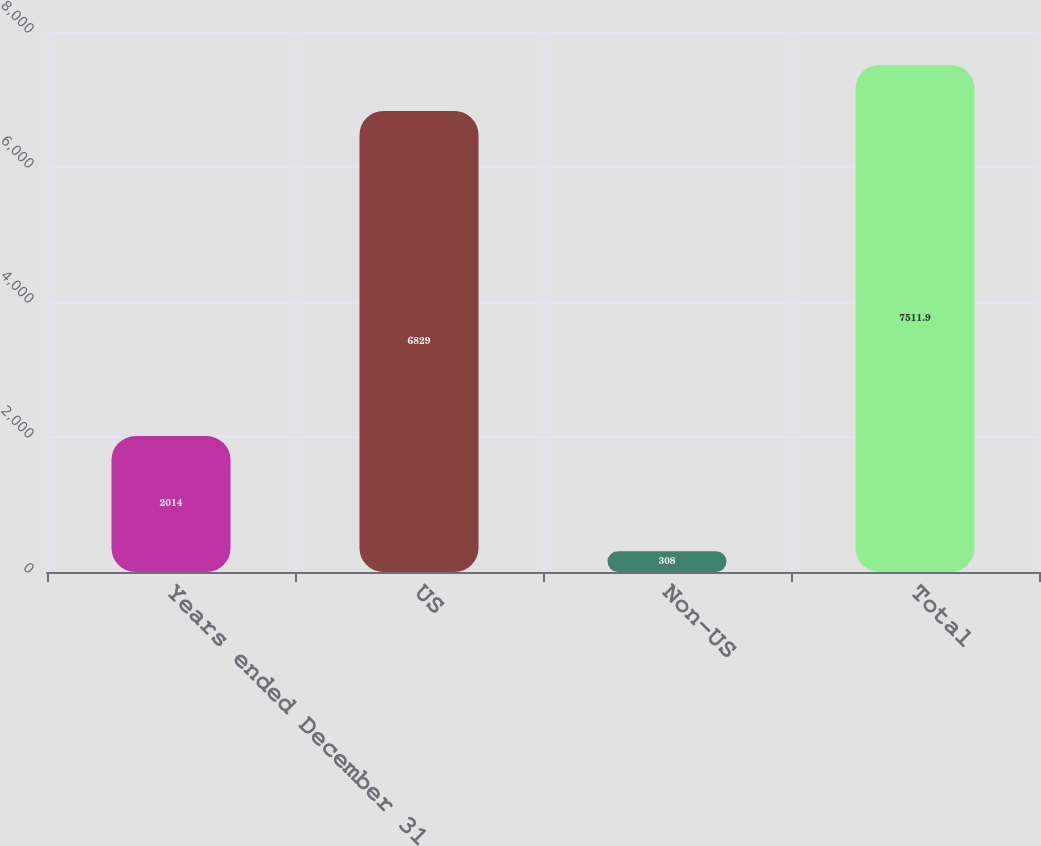Convert chart to OTSL. <chart><loc_0><loc_0><loc_500><loc_500><bar_chart><fcel>Years ended December 31<fcel>US<fcel>Non-US<fcel>Total<nl><fcel>2014<fcel>6829<fcel>308<fcel>7511.9<nl></chart> 